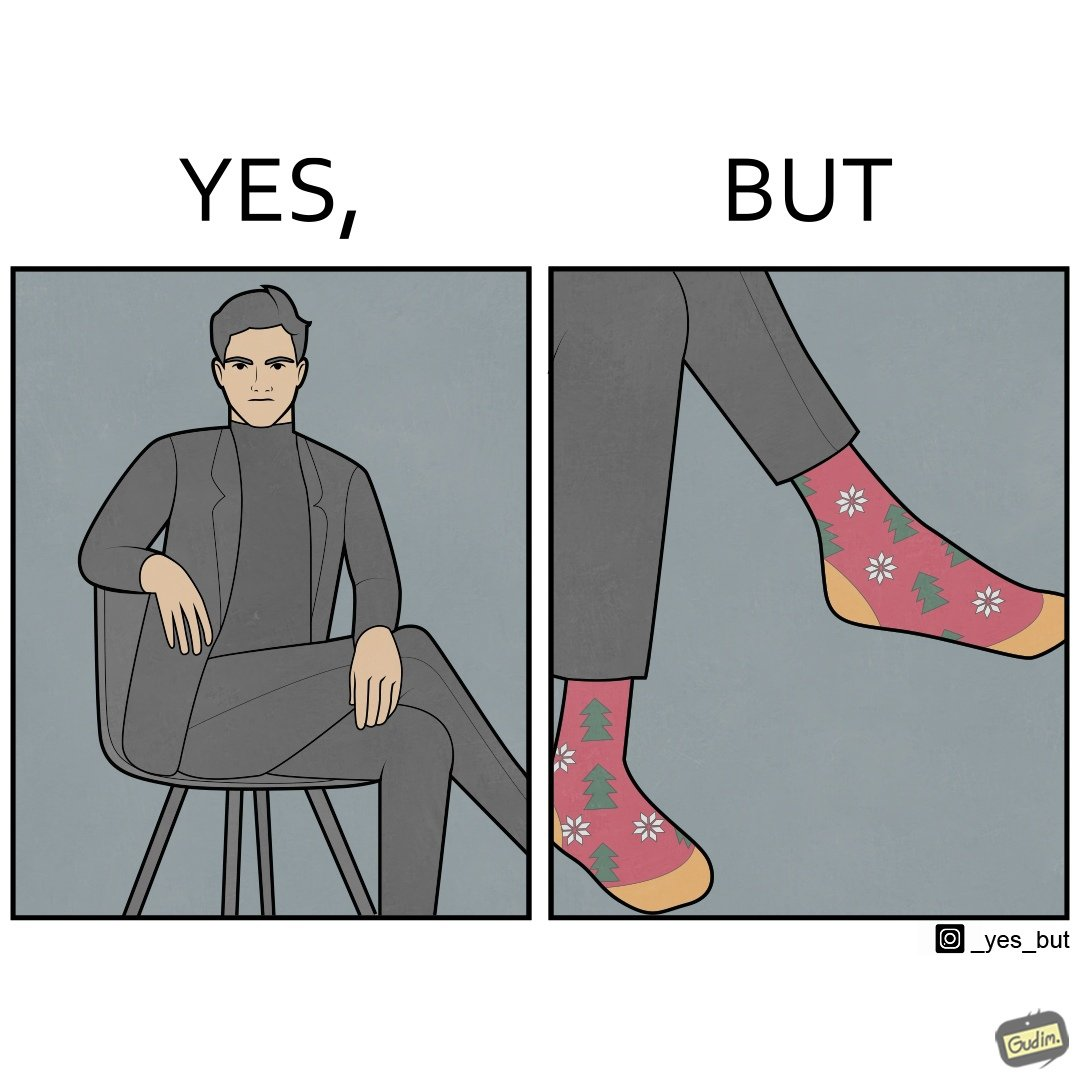What does this image depict? The image is ironical, as the person wearing a formal black suit and pants, is wearing colorful socks, probably due to the reason that socks are not visible while wearing shoes, and hence, do not need to be formal. 